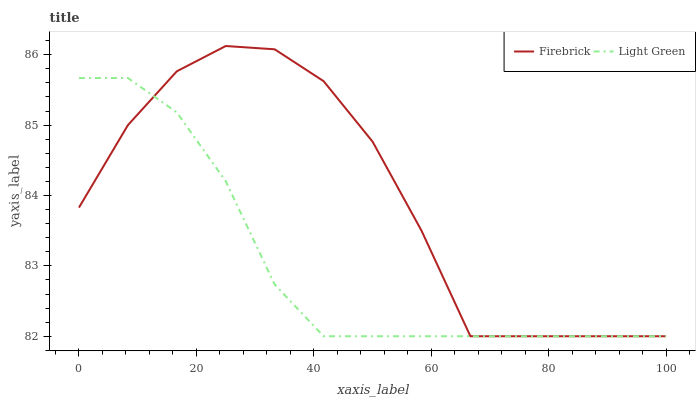Does Light Green have the minimum area under the curve?
Answer yes or no. Yes. Does Firebrick have the maximum area under the curve?
Answer yes or no. Yes. Does Light Green have the maximum area under the curve?
Answer yes or no. No. Is Light Green the smoothest?
Answer yes or no. Yes. Is Firebrick the roughest?
Answer yes or no. Yes. Is Light Green the roughest?
Answer yes or no. No. Does Firebrick have the lowest value?
Answer yes or no. Yes. Does Firebrick have the highest value?
Answer yes or no. Yes. Does Light Green have the highest value?
Answer yes or no. No. Does Firebrick intersect Light Green?
Answer yes or no. Yes. Is Firebrick less than Light Green?
Answer yes or no. No. Is Firebrick greater than Light Green?
Answer yes or no. No. 